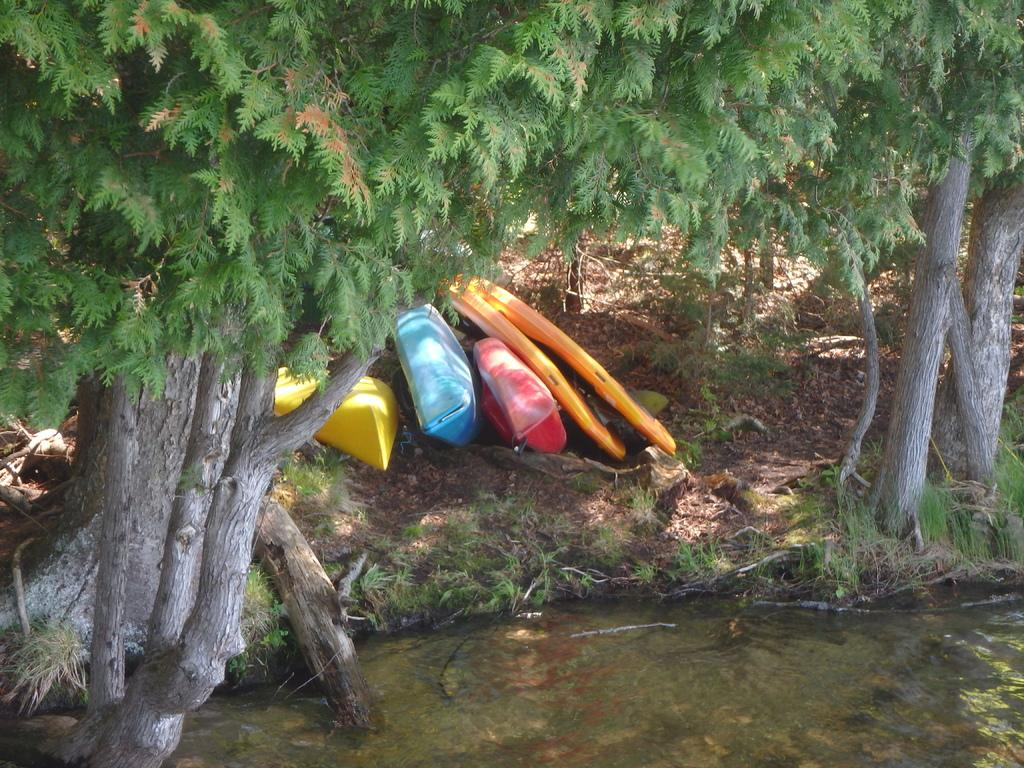What type of vegetation can be seen in the image? There are trees in the image. What natural feature is present alongside the trees? There is a water body in the image. What can be seen floating on the water body? There are boats in the image. What type of ground cover is present near the water body? There is grass on the land alongside the water in the image. Can you see a ring on the water in the image? There is no ring visible on the water in the image. Is there a plastic object floating in the water in the image? There is no plastic object mentioned in the image; only boats are mentioned. 